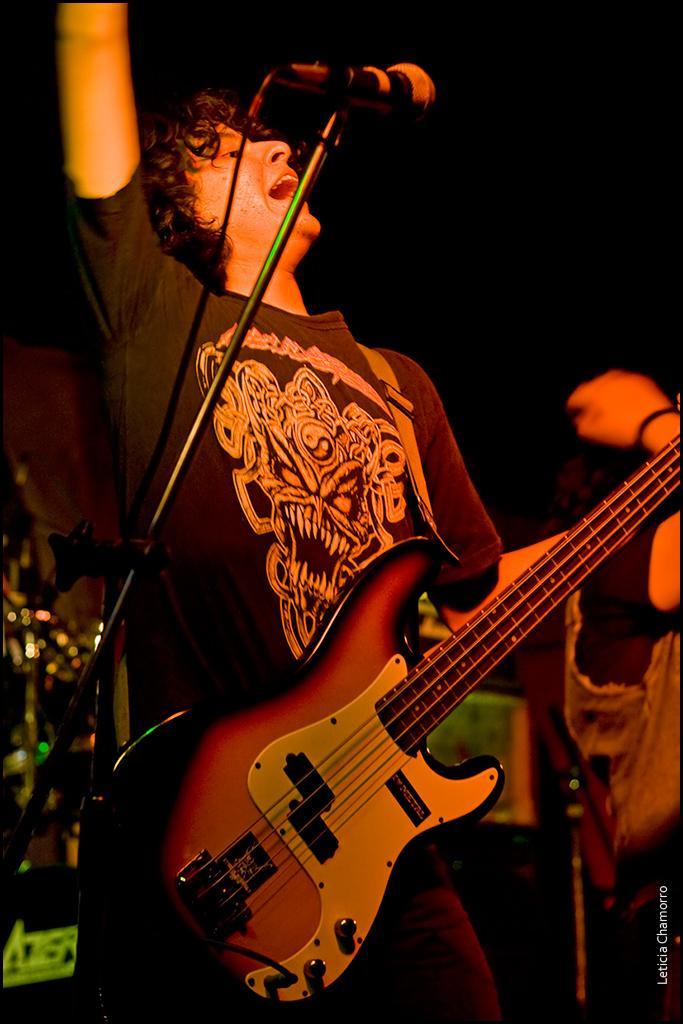How would you summarize this image in a sentence or two? In this picture, In the middle there is a boy standing and he is holding a music instrument which is in yellow color, In the left side there is a microphone in black color and he is singing in the microphone, In the background there is a person standing. 